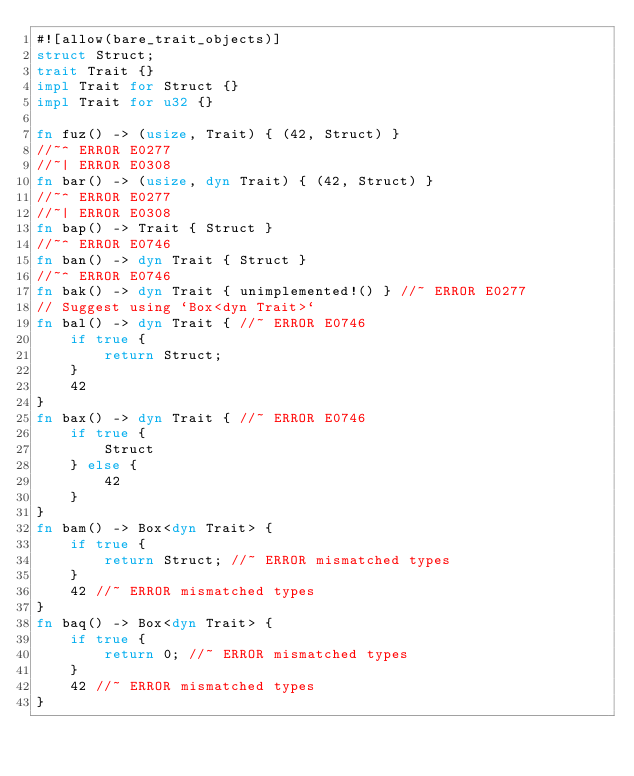Convert code to text. <code><loc_0><loc_0><loc_500><loc_500><_Rust_>#![allow(bare_trait_objects)]
struct Struct;
trait Trait {}
impl Trait for Struct {}
impl Trait for u32 {}

fn fuz() -> (usize, Trait) { (42, Struct) }
//~^ ERROR E0277
//~| ERROR E0308
fn bar() -> (usize, dyn Trait) { (42, Struct) }
//~^ ERROR E0277
//~| ERROR E0308
fn bap() -> Trait { Struct }
//~^ ERROR E0746
fn ban() -> dyn Trait { Struct }
//~^ ERROR E0746
fn bak() -> dyn Trait { unimplemented!() } //~ ERROR E0277
// Suggest using `Box<dyn Trait>`
fn bal() -> dyn Trait { //~ ERROR E0746
    if true {
        return Struct;
    }
    42
}
fn bax() -> dyn Trait { //~ ERROR E0746
    if true {
        Struct
    } else {
        42
    }
}
fn bam() -> Box<dyn Trait> {
    if true {
        return Struct; //~ ERROR mismatched types
    }
    42 //~ ERROR mismatched types
}
fn baq() -> Box<dyn Trait> {
    if true {
        return 0; //~ ERROR mismatched types
    }
    42 //~ ERROR mismatched types
}</code> 